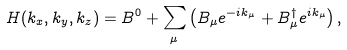<formula> <loc_0><loc_0><loc_500><loc_500>H ( k _ { x } , k _ { y } , k _ { z } ) = B ^ { 0 } + \sum _ { \mu } \left ( B _ { \mu } e ^ { - i k _ { \mu } } + B _ { \mu } ^ { \dag } e ^ { i k _ { \mu } } \right ) ,</formula> 